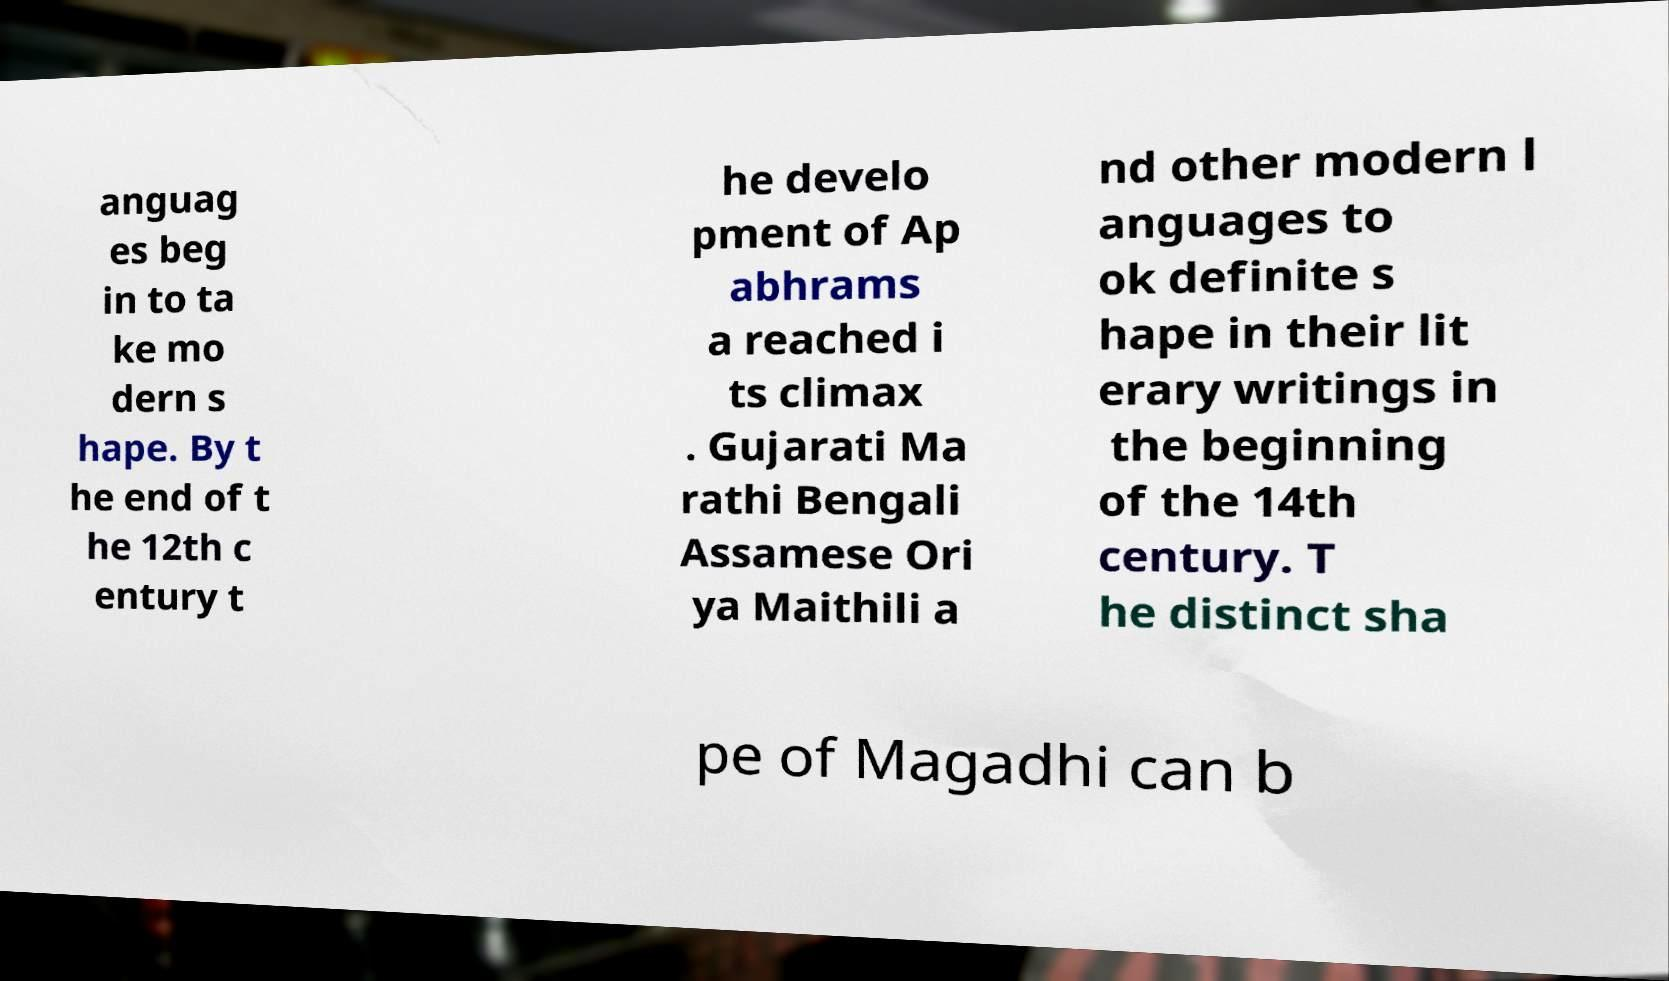For documentation purposes, I need the text within this image transcribed. Could you provide that? anguag es beg in to ta ke mo dern s hape. By t he end of t he 12th c entury t he develo pment of Ap abhrams a reached i ts climax . Gujarati Ma rathi Bengali Assamese Ori ya Maithili a nd other modern l anguages to ok definite s hape in their lit erary writings in the beginning of the 14th century. T he distinct sha pe of Magadhi can b 